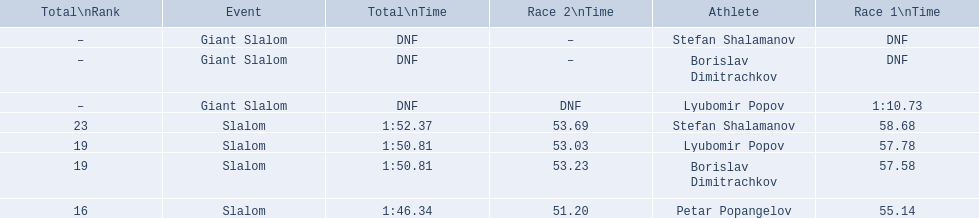What are all the competitions lyubomir popov competed in? Lyubomir Popov, Lyubomir Popov. Of those, which were giant slalom races? Giant Slalom. What was his time in race 1? 1:10.73. 